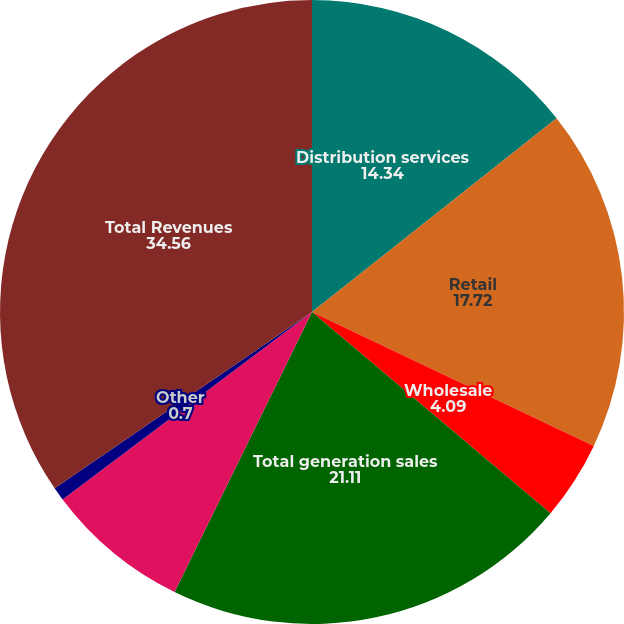<chart> <loc_0><loc_0><loc_500><loc_500><pie_chart><fcel>Distribution services<fcel>Retail<fcel>Wholesale<fcel>Total generation sales<fcel>Total transmission sales<fcel>Other<fcel>Total Revenues<nl><fcel>14.34%<fcel>17.72%<fcel>4.09%<fcel>21.11%<fcel>7.48%<fcel>0.7%<fcel>34.56%<nl></chart> 